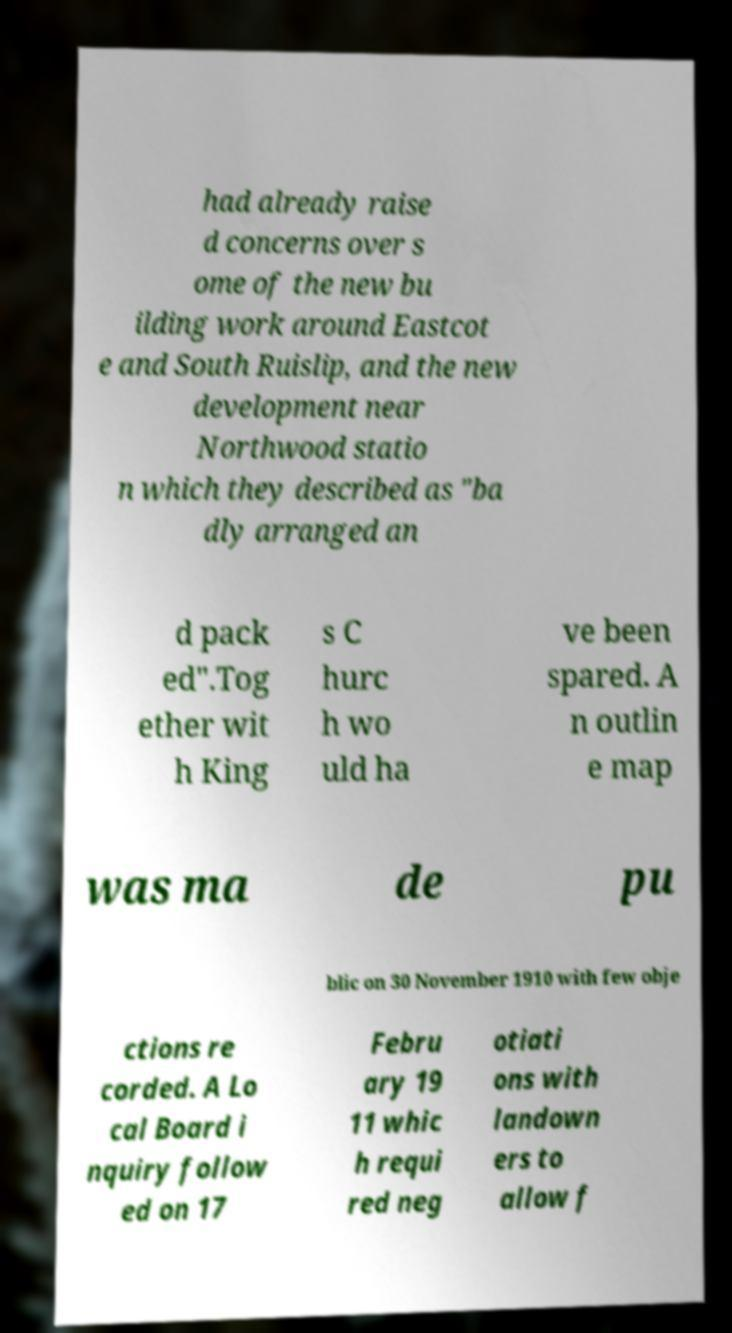I need the written content from this picture converted into text. Can you do that? had already raise d concerns over s ome of the new bu ilding work around Eastcot e and South Ruislip, and the new development near Northwood statio n which they described as "ba dly arranged an d pack ed".Tog ether wit h King s C hurc h wo uld ha ve been spared. A n outlin e map was ma de pu blic on 30 November 1910 with few obje ctions re corded. A Lo cal Board i nquiry follow ed on 17 Febru ary 19 11 whic h requi red neg otiati ons with landown ers to allow f 